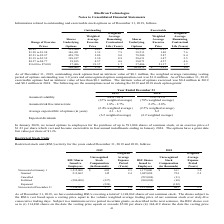According to Ricebran Technologies's financial document, As of December 31, 2019, what is the intrinsic value of the outstanding stock options? According to the financial document, $0.1 million. The relevant text states: "utstanding stock options had an intrinsic value of $0.1 million, the weighted average remaining vesting period of options outstanding was 3.0 years and unrecognize utstanding stock options had an intr..." Also, What was the intrinsic value of options exercised in 2019 and 2018 respectively? The document shows two values: $0.4 million and $0.1 million. From the document: "utstanding stock options had an intrinsic value of $0.1 million, the weighted average remaining vesting period of options outstanding was 3.0 years an..." Also, What are the respective assumed volatility in 2018 and 2019 respectively? The document shows two values: 75% - 81% and 64% - 69%. From the document: "Assumed volatility 64% - 69% 75% - 81% Assumed volatility 64% - 69% 75% - 81%..." Also, can you calculate: What is the average assumed risk free rate in 2018? To answer this question, I need to perform calculations using the financial data. The calculation is: (2.2 + 2.8)/2 , which equals 2.5 (percentage). This is based on the information: "Assumed risk free interest rate 1.8% - 2.7% 2.2% - 2.8% Assumed risk free interest rate 1.8% - 2.7% 2.2% - 2.8%..." The key data points involved are: 2.2, 2.8. Also, can you calculate: What is the average assumed risk free rate in 2019? To answer this question, I need to perform calculations using the financial data. The calculation is: (1.8 + 2.7)/2 , which equals 2.25 (percentage). This is based on the information: "Assumed risk free interest rate 1.8% - 2.7% 2.2% - 2.8% Assumed risk free interest rate 1.8% - 2.7% 2.2% - 2.8%..." The key data points involved are: 1.8, 2.7. Also, can you calculate: What is the average assumed volatility in 2018? To answer this question, I need to perform calculations using the financial data. The calculation is: (75 + 81)/2 , which equals 78 (percentage). This is based on the information: "Assumed volatility 64% - 69% 75% - 81% Assumed volatility 64% - 69% 75% - 81%..." The key data points involved are: 75, 81. 